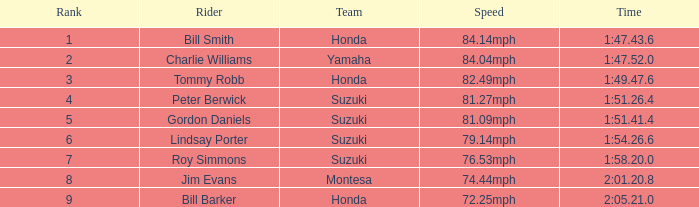What was peter berwick of team suzuki's recorded time? 1:51.26.4. 